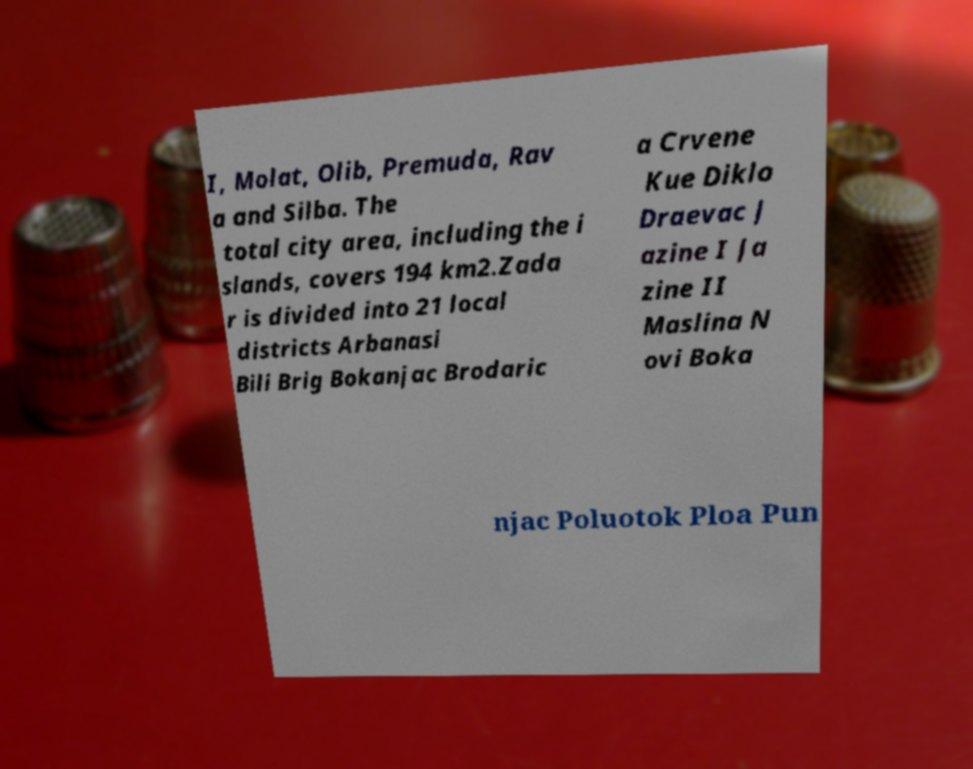What messages or text are displayed in this image? I need them in a readable, typed format. I, Molat, Olib, Premuda, Rav a and Silba. The total city area, including the i slands, covers 194 km2.Zada r is divided into 21 local districts Arbanasi Bili Brig Bokanjac Brodaric a Crvene Kue Diklo Draevac J azine I Ja zine II Maslina N ovi Boka njac Poluotok Ploa Pun 